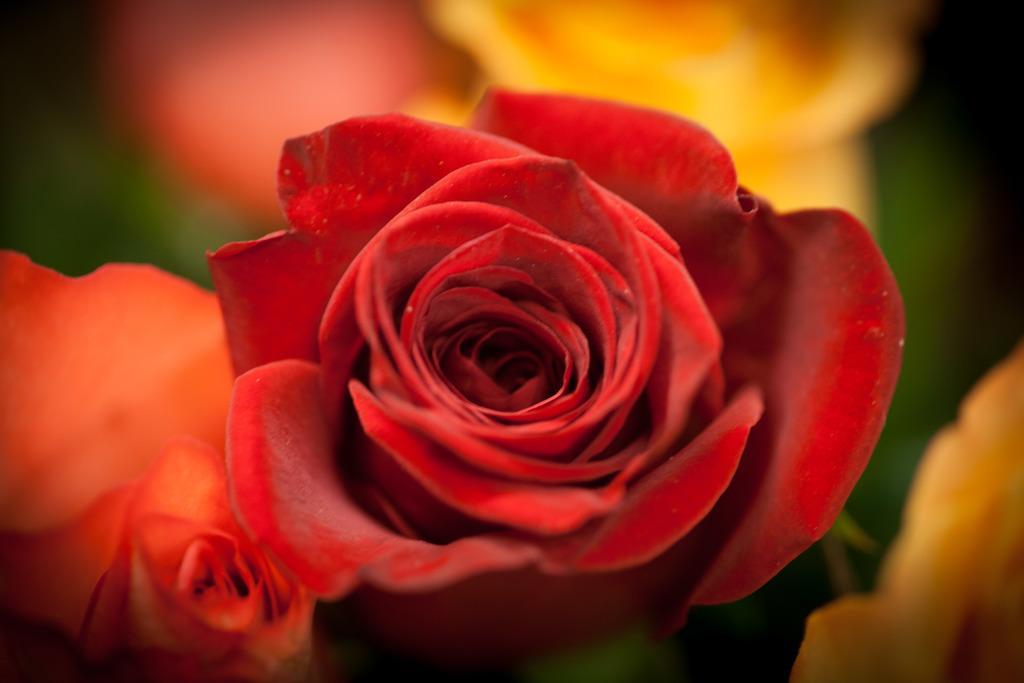Could you give a brief overview of what you see in this image? This is the picture of two roses which are in red and orange color. 